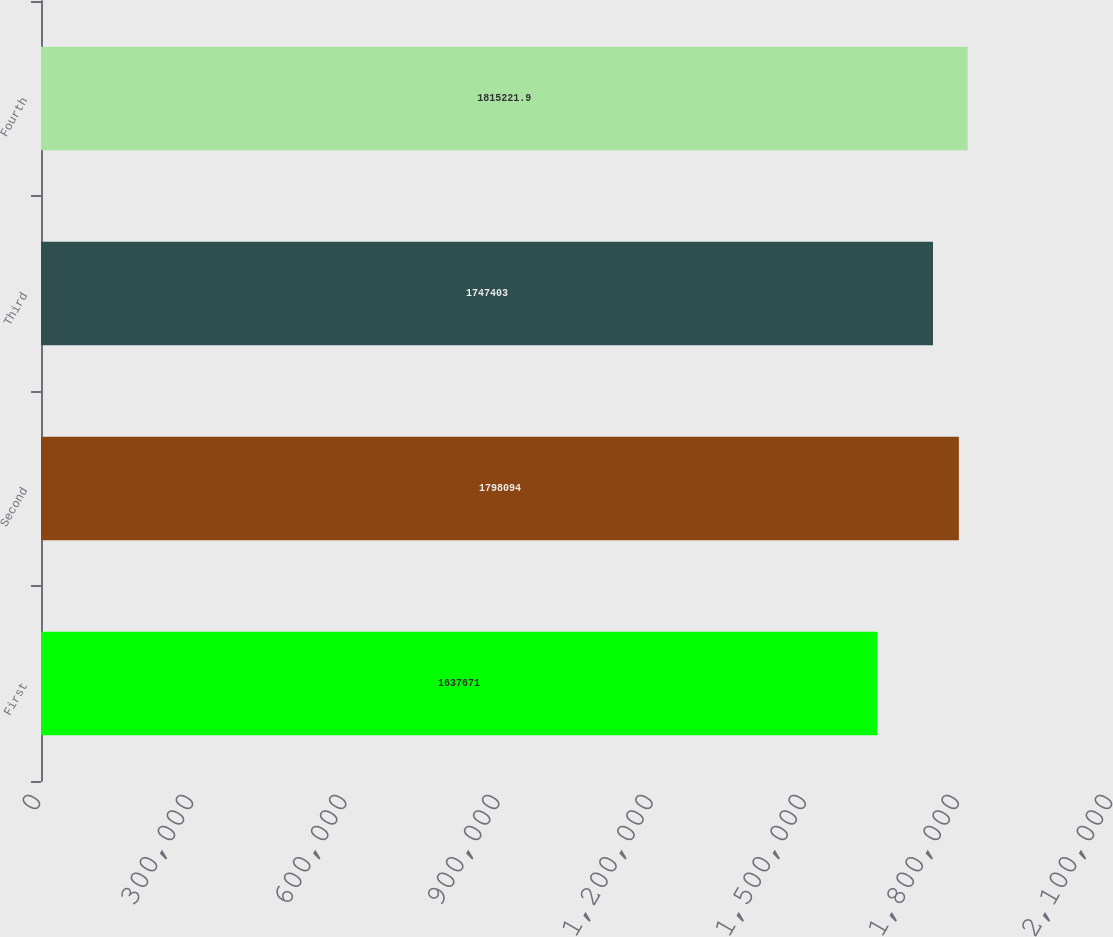Convert chart to OTSL. <chart><loc_0><loc_0><loc_500><loc_500><bar_chart><fcel>First<fcel>Second<fcel>Third<fcel>Fourth<nl><fcel>1.63767e+06<fcel>1.79809e+06<fcel>1.7474e+06<fcel>1.81522e+06<nl></chart> 